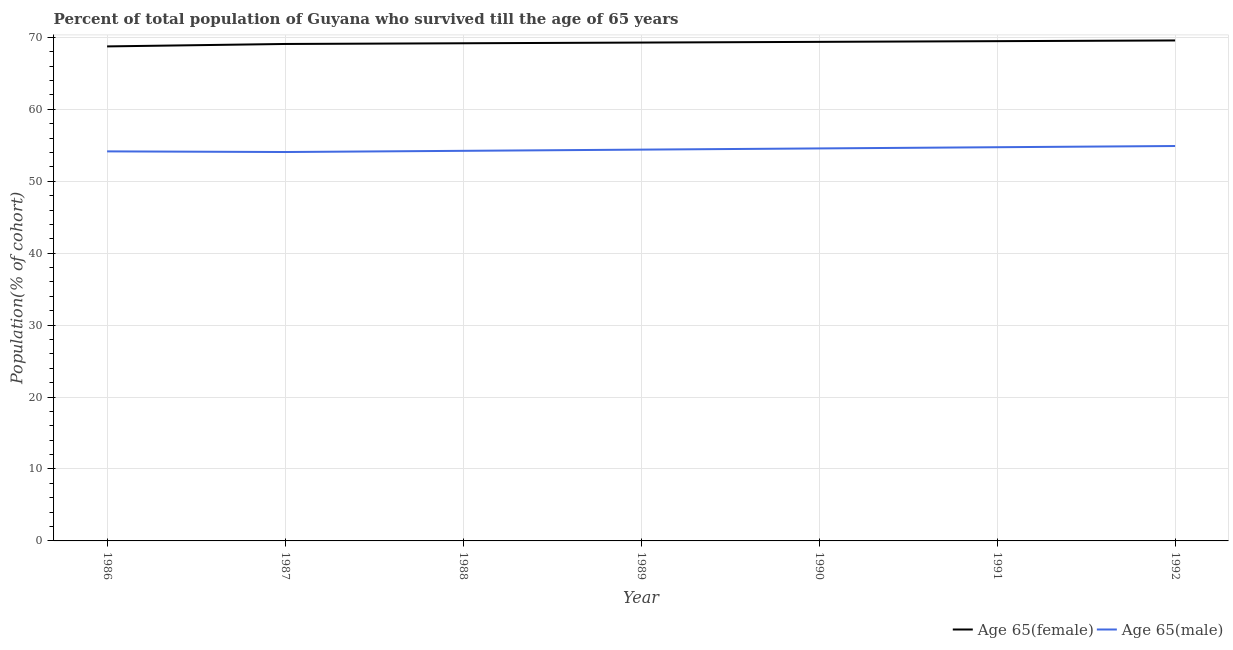Does the line corresponding to percentage of female population who survived till age of 65 intersect with the line corresponding to percentage of male population who survived till age of 65?
Ensure brevity in your answer.  No. Is the number of lines equal to the number of legend labels?
Give a very brief answer. Yes. What is the percentage of male population who survived till age of 65 in 1990?
Make the answer very short. 54.56. Across all years, what is the maximum percentage of female population who survived till age of 65?
Give a very brief answer. 69.57. Across all years, what is the minimum percentage of male population who survived till age of 65?
Offer a very short reply. 54.06. What is the total percentage of female population who survived till age of 65 in the graph?
Your response must be concise. 484.69. What is the difference between the percentage of female population who survived till age of 65 in 1987 and that in 1988?
Offer a terse response. -0.1. What is the difference between the percentage of female population who survived till age of 65 in 1992 and the percentage of male population who survived till age of 65 in 1988?
Provide a short and direct response. 15.34. What is the average percentage of male population who survived till age of 65 per year?
Make the answer very short. 54.43. In the year 1991, what is the difference between the percentage of female population who survived till age of 65 and percentage of male population who survived till age of 65?
Offer a terse response. 14.74. In how many years, is the percentage of male population who survived till age of 65 greater than 8 %?
Ensure brevity in your answer.  7. What is the ratio of the percentage of male population who survived till age of 65 in 1986 to that in 1988?
Your answer should be very brief. 1. Is the percentage of female population who survived till age of 65 in 1987 less than that in 1989?
Offer a very short reply. Yes. What is the difference between the highest and the second highest percentage of male population who survived till age of 65?
Your answer should be very brief. 0.17. What is the difference between the highest and the lowest percentage of male population who survived till age of 65?
Offer a very short reply. 0.84. Is the sum of the percentage of female population who survived till age of 65 in 1987 and 1990 greater than the maximum percentage of male population who survived till age of 65 across all years?
Your answer should be compact. Yes. Does the percentage of female population who survived till age of 65 monotonically increase over the years?
Ensure brevity in your answer.  Yes. Is the percentage of male population who survived till age of 65 strictly greater than the percentage of female population who survived till age of 65 over the years?
Your answer should be compact. No. How many lines are there?
Your answer should be very brief. 2. How many years are there in the graph?
Offer a very short reply. 7. What is the difference between two consecutive major ticks on the Y-axis?
Your response must be concise. 10. How are the legend labels stacked?
Your answer should be very brief. Horizontal. What is the title of the graph?
Make the answer very short. Percent of total population of Guyana who survived till the age of 65 years. Does "Study and work" appear as one of the legend labels in the graph?
Keep it short and to the point. No. What is the label or title of the X-axis?
Your answer should be compact. Year. What is the label or title of the Y-axis?
Keep it short and to the point. Population(% of cohort). What is the Population(% of cohort) of Age 65(female) in 1986?
Provide a succinct answer. 68.74. What is the Population(% of cohort) in Age 65(male) in 1986?
Your answer should be very brief. 54.15. What is the Population(% of cohort) of Age 65(female) in 1987?
Provide a succinct answer. 69.08. What is the Population(% of cohort) in Age 65(male) in 1987?
Provide a short and direct response. 54.06. What is the Population(% of cohort) of Age 65(female) in 1988?
Your answer should be very brief. 69.18. What is the Population(% of cohort) in Age 65(male) in 1988?
Give a very brief answer. 54.23. What is the Population(% of cohort) in Age 65(female) in 1989?
Ensure brevity in your answer.  69.28. What is the Population(% of cohort) in Age 65(male) in 1989?
Ensure brevity in your answer.  54.39. What is the Population(% of cohort) in Age 65(female) in 1990?
Make the answer very short. 69.37. What is the Population(% of cohort) of Age 65(male) in 1990?
Offer a terse response. 54.56. What is the Population(% of cohort) of Age 65(female) in 1991?
Your answer should be compact. 69.47. What is the Population(% of cohort) in Age 65(male) in 1991?
Provide a short and direct response. 54.73. What is the Population(% of cohort) in Age 65(female) in 1992?
Ensure brevity in your answer.  69.57. What is the Population(% of cohort) in Age 65(male) in 1992?
Your response must be concise. 54.89. Across all years, what is the maximum Population(% of cohort) in Age 65(female)?
Your answer should be very brief. 69.57. Across all years, what is the maximum Population(% of cohort) of Age 65(male)?
Make the answer very short. 54.89. Across all years, what is the minimum Population(% of cohort) of Age 65(female)?
Keep it short and to the point. 68.74. Across all years, what is the minimum Population(% of cohort) of Age 65(male)?
Give a very brief answer. 54.06. What is the total Population(% of cohort) of Age 65(female) in the graph?
Ensure brevity in your answer.  484.69. What is the total Population(% of cohort) of Age 65(male) in the graph?
Provide a succinct answer. 381.01. What is the difference between the Population(% of cohort) of Age 65(female) in 1986 and that in 1987?
Keep it short and to the point. -0.34. What is the difference between the Population(% of cohort) in Age 65(male) in 1986 and that in 1987?
Your answer should be compact. 0.09. What is the difference between the Population(% of cohort) of Age 65(female) in 1986 and that in 1988?
Your response must be concise. -0.44. What is the difference between the Population(% of cohort) in Age 65(male) in 1986 and that in 1988?
Provide a short and direct response. -0.08. What is the difference between the Population(% of cohort) of Age 65(female) in 1986 and that in 1989?
Your answer should be compact. -0.53. What is the difference between the Population(% of cohort) in Age 65(male) in 1986 and that in 1989?
Keep it short and to the point. -0.24. What is the difference between the Population(% of cohort) of Age 65(female) in 1986 and that in 1990?
Keep it short and to the point. -0.63. What is the difference between the Population(% of cohort) of Age 65(male) in 1986 and that in 1990?
Provide a short and direct response. -0.41. What is the difference between the Population(% of cohort) in Age 65(female) in 1986 and that in 1991?
Ensure brevity in your answer.  -0.73. What is the difference between the Population(% of cohort) in Age 65(male) in 1986 and that in 1991?
Your answer should be very brief. -0.58. What is the difference between the Population(% of cohort) in Age 65(female) in 1986 and that in 1992?
Offer a terse response. -0.83. What is the difference between the Population(% of cohort) in Age 65(male) in 1986 and that in 1992?
Your answer should be very brief. -0.75. What is the difference between the Population(% of cohort) of Age 65(female) in 1987 and that in 1988?
Offer a very short reply. -0.1. What is the difference between the Population(% of cohort) of Age 65(male) in 1987 and that in 1988?
Provide a succinct answer. -0.17. What is the difference between the Population(% of cohort) of Age 65(female) in 1987 and that in 1989?
Provide a succinct answer. -0.2. What is the difference between the Population(% of cohort) of Age 65(male) in 1987 and that in 1989?
Keep it short and to the point. -0.33. What is the difference between the Population(% of cohort) of Age 65(female) in 1987 and that in 1990?
Offer a very short reply. -0.29. What is the difference between the Population(% of cohort) in Age 65(male) in 1987 and that in 1990?
Give a very brief answer. -0.5. What is the difference between the Population(% of cohort) in Age 65(female) in 1987 and that in 1991?
Make the answer very short. -0.39. What is the difference between the Population(% of cohort) in Age 65(male) in 1987 and that in 1991?
Give a very brief answer. -0.67. What is the difference between the Population(% of cohort) of Age 65(female) in 1987 and that in 1992?
Your answer should be very brief. -0.49. What is the difference between the Population(% of cohort) of Age 65(male) in 1987 and that in 1992?
Your response must be concise. -0.84. What is the difference between the Population(% of cohort) of Age 65(female) in 1988 and that in 1989?
Offer a very short reply. -0.1. What is the difference between the Population(% of cohort) in Age 65(male) in 1988 and that in 1989?
Provide a short and direct response. -0.17. What is the difference between the Population(% of cohort) of Age 65(female) in 1988 and that in 1990?
Ensure brevity in your answer.  -0.2. What is the difference between the Population(% of cohort) in Age 65(male) in 1988 and that in 1990?
Ensure brevity in your answer.  -0.33. What is the difference between the Population(% of cohort) of Age 65(female) in 1988 and that in 1991?
Ensure brevity in your answer.  -0.29. What is the difference between the Population(% of cohort) of Age 65(male) in 1988 and that in 1991?
Your answer should be compact. -0.5. What is the difference between the Population(% of cohort) in Age 65(female) in 1988 and that in 1992?
Keep it short and to the point. -0.39. What is the difference between the Population(% of cohort) of Age 65(male) in 1988 and that in 1992?
Provide a succinct answer. -0.67. What is the difference between the Population(% of cohort) in Age 65(female) in 1989 and that in 1990?
Give a very brief answer. -0.1. What is the difference between the Population(% of cohort) in Age 65(male) in 1989 and that in 1990?
Ensure brevity in your answer.  -0.17. What is the difference between the Population(% of cohort) of Age 65(female) in 1989 and that in 1991?
Make the answer very short. -0.2. What is the difference between the Population(% of cohort) in Age 65(male) in 1989 and that in 1991?
Ensure brevity in your answer.  -0.33. What is the difference between the Population(% of cohort) of Age 65(female) in 1989 and that in 1992?
Offer a terse response. -0.29. What is the difference between the Population(% of cohort) in Age 65(male) in 1989 and that in 1992?
Your answer should be compact. -0.5. What is the difference between the Population(% of cohort) of Age 65(female) in 1990 and that in 1991?
Offer a terse response. -0.1. What is the difference between the Population(% of cohort) in Age 65(male) in 1990 and that in 1991?
Provide a succinct answer. -0.17. What is the difference between the Population(% of cohort) of Age 65(female) in 1990 and that in 1992?
Your answer should be compact. -0.2. What is the difference between the Population(% of cohort) of Age 65(male) in 1990 and that in 1992?
Make the answer very short. -0.33. What is the difference between the Population(% of cohort) in Age 65(female) in 1991 and that in 1992?
Offer a very short reply. -0.1. What is the difference between the Population(% of cohort) in Age 65(male) in 1991 and that in 1992?
Provide a short and direct response. -0.17. What is the difference between the Population(% of cohort) in Age 65(female) in 1986 and the Population(% of cohort) in Age 65(male) in 1987?
Provide a short and direct response. 14.68. What is the difference between the Population(% of cohort) of Age 65(female) in 1986 and the Population(% of cohort) of Age 65(male) in 1988?
Your answer should be very brief. 14.51. What is the difference between the Population(% of cohort) in Age 65(female) in 1986 and the Population(% of cohort) in Age 65(male) in 1989?
Make the answer very short. 14.35. What is the difference between the Population(% of cohort) of Age 65(female) in 1986 and the Population(% of cohort) of Age 65(male) in 1990?
Your answer should be very brief. 14.18. What is the difference between the Population(% of cohort) of Age 65(female) in 1986 and the Population(% of cohort) of Age 65(male) in 1991?
Offer a terse response. 14.01. What is the difference between the Population(% of cohort) in Age 65(female) in 1986 and the Population(% of cohort) in Age 65(male) in 1992?
Offer a very short reply. 13.85. What is the difference between the Population(% of cohort) of Age 65(female) in 1987 and the Population(% of cohort) of Age 65(male) in 1988?
Your response must be concise. 14.85. What is the difference between the Population(% of cohort) of Age 65(female) in 1987 and the Population(% of cohort) of Age 65(male) in 1989?
Keep it short and to the point. 14.69. What is the difference between the Population(% of cohort) in Age 65(female) in 1987 and the Population(% of cohort) in Age 65(male) in 1990?
Your response must be concise. 14.52. What is the difference between the Population(% of cohort) in Age 65(female) in 1987 and the Population(% of cohort) in Age 65(male) in 1991?
Offer a very short reply. 14.35. What is the difference between the Population(% of cohort) of Age 65(female) in 1987 and the Population(% of cohort) of Age 65(male) in 1992?
Keep it short and to the point. 14.19. What is the difference between the Population(% of cohort) in Age 65(female) in 1988 and the Population(% of cohort) in Age 65(male) in 1989?
Give a very brief answer. 14.78. What is the difference between the Population(% of cohort) of Age 65(female) in 1988 and the Population(% of cohort) of Age 65(male) in 1990?
Keep it short and to the point. 14.62. What is the difference between the Population(% of cohort) in Age 65(female) in 1988 and the Population(% of cohort) in Age 65(male) in 1991?
Provide a succinct answer. 14.45. What is the difference between the Population(% of cohort) of Age 65(female) in 1988 and the Population(% of cohort) of Age 65(male) in 1992?
Offer a very short reply. 14.28. What is the difference between the Population(% of cohort) of Age 65(female) in 1989 and the Population(% of cohort) of Age 65(male) in 1990?
Keep it short and to the point. 14.71. What is the difference between the Population(% of cohort) in Age 65(female) in 1989 and the Population(% of cohort) in Age 65(male) in 1991?
Keep it short and to the point. 14.55. What is the difference between the Population(% of cohort) of Age 65(female) in 1989 and the Population(% of cohort) of Age 65(male) in 1992?
Keep it short and to the point. 14.38. What is the difference between the Population(% of cohort) in Age 65(female) in 1990 and the Population(% of cohort) in Age 65(male) in 1991?
Provide a short and direct response. 14.65. What is the difference between the Population(% of cohort) of Age 65(female) in 1990 and the Population(% of cohort) of Age 65(male) in 1992?
Offer a very short reply. 14.48. What is the difference between the Population(% of cohort) of Age 65(female) in 1991 and the Population(% of cohort) of Age 65(male) in 1992?
Your answer should be very brief. 14.58. What is the average Population(% of cohort) of Age 65(female) per year?
Your answer should be compact. 69.24. What is the average Population(% of cohort) of Age 65(male) per year?
Your answer should be compact. 54.43. In the year 1986, what is the difference between the Population(% of cohort) of Age 65(female) and Population(% of cohort) of Age 65(male)?
Your response must be concise. 14.59. In the year 1987, what is the difference between the Population(% of cohort) in Age 65(female) and Population(% of cohort) in Age 65(male)?
Provide a succinct answer. 15.02. In the year 1988, what is the difference between the Population(% of cohort) in Age 65(female) and Population(% of cohort) in Age 65(male)?
Make the answer very short. 14.95. In the year 1989, what is the difference between the Population(% of cohort) in Age 65(female) and Population(% of cohort) in Age 65(male)?
Provide a succinct answer. 14.88. In the year 1990, what is the difference between the Population(% of cohort) of Age 65(female) and Population(% of cohort) of Age 65(male)?
Ensure brevity in your answer.  14.81. In the year 1991, what is the difference between the Population(% of cohort) of Age 65(female) and Population(% of cohort) of Age 65(male)?
Your answer should be very brief. 14.74. In the year 1992, what is the difference between the Population(% of cohort) of Age 65(female) and Population(% of cohort) of Age 65(male)?
Provide a succinct answer. 14.67. What is the ratio of the Population(% of cohort) of Age 65(female) in 1986 to that in 1988?
Provide a succinct answer. 0.99. What is the ratio of the Population(% of cohort) of Age 65(male) in 1986 to that in 1988?
Your answer should be very brief. 1. What is the ratio of the Population(% of cohort) in Age 65(female) in 1986 to that in 1990?
Ensure brevity in your answer.  0.99. What is the ratio of the Population(% of cohort) of Age 65(female) in 1986 to that in 1992?
Your response must be concise. 0.99. What is the ratio of the Population(% of cohort) of Age 65(male) in 1986 to that in 1992?
Offer a very short reply. 0.99. What is the ratio of the Population(% of cohort) in Age 65(female) in 1987 to that in 1988?
Offer a very short reply. 1. What is the ratio of the Population(% of cohort) in Age 65(female) in 1987 to that in 1990?
Your response must be concise. 1. What is the ratio of the Population(% of cohort) in Age 65(male) in 1987 to that in 1990?
Provide a short and direct response. 0.99. What is the ratio of the Population(% of cohort) in Age 65(male) in 1987 to that in 1991?
Ensure brevity in your answer.  0.99. What is the ratio of the Population(% of cohort) of Age 65(male) in 1987 to that in 1992?
Ensure brevity in your answer.  0.98. What is the ratio of the Population(% of cohort) of Age 65(female) in 1988 to that in 1989?
Your answer should be very brief. 1. What is the ratio of the Population(% of cohort) of Age 65(male) in 1988 to that in 1990?
Make the answer very short. 0.99. What is the ratio of the Population(% of cohort) in Age 65(female) in 1988 to that in 1991?
Provide a short and direct response. 1. What is the ratio of the Population(% of cohort) of Age 65(male) in 1988 to that in 1992?
Offer a very short reply. 0.99. What is the ratio of the Population(% of cohort) in Age 65(female) in 1989 to that in 1991?
Give a very brief answer. 1. What is the ratio of the Population(% of cohort) of Age 65(male) in 1989 to that in 1991?
Offer a very short reply. 0.99. What is the ratio of the Population(% of cohort) of Age 65(female) in 1989 to that in 1992?
Provide a succinct answer. 1. What is the ratio of the Population(% of cohort) in Age 65(male) in 1989 to that in 1992?
Provide a short and direct response. 0.99. What is the ratio of the Population(% of cohort) in Age 65(female) in 1990 to that in 1992?
Your response must be concise. 1. What is the ratio of the Population(% of cohort) in Age 65(male) in 1991 to that in 1992?
Your response must be concise. 1. What is the difference between the highest and the second highest Population(% of cohort) in Age 65(female)?
Your response must be concise. 0.1. What is the difference between the highest and the second highest Population(% of cohort) in Age 65(male)?
Your answer should be very brief. 0.17. What is the difference between the highest and the lowest Population(% of cohort) in Age 65(female)?
Offer a terse response. 0.83. What is the difference between the highest and the lowest Population(% of cohort) in Age 65(male)?
Your answer should be compact. 0.84. 